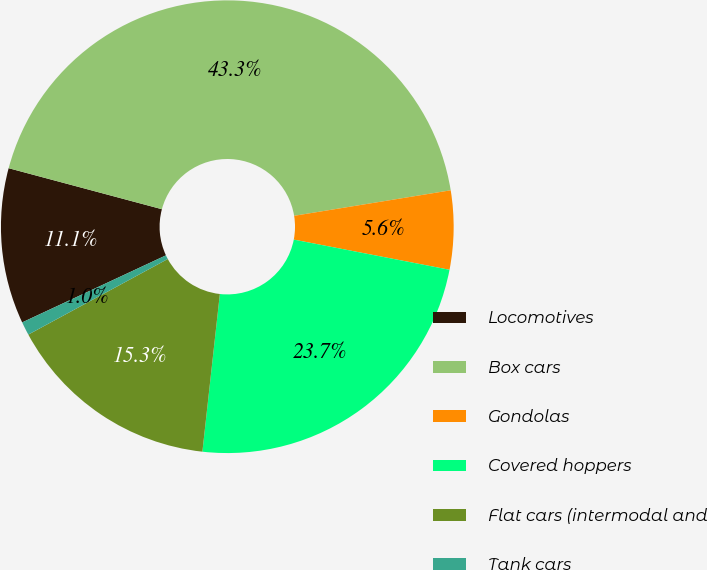Convert chart to OTSL. <chart><loc_0><loc_0><loc_500><loc_500><pie_chart><fcel>Locomotives<fcel>Box cars<fcel>Gondolas<fcel>Covered hoppers<fcel>Flat cars (intermodal and<fcel>Tank cars<nl><fcel>11.11%<fcel>43.27%<fcel>5.62%<fcel>23.71%<fcel>15.34%<fcel>0.96%<nl></chart> 